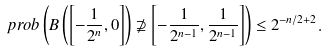Convert formula to latex. <formula><loc_0><loc_0><loc_500><loc_500>\ p r o b \left ( B \left ( \left [ - \frac { 1 } { 2 ^ { n } } , 0 \right ] \right ) \not \supseteq \left [ - \frac { 1 } { 2 ^ { n - 1 } } , \frac { 1 } { 2 ^ { n - 1 } } \right ] \right ) \leq 2 ^ { - n / 2 + 2 } .</formula> 